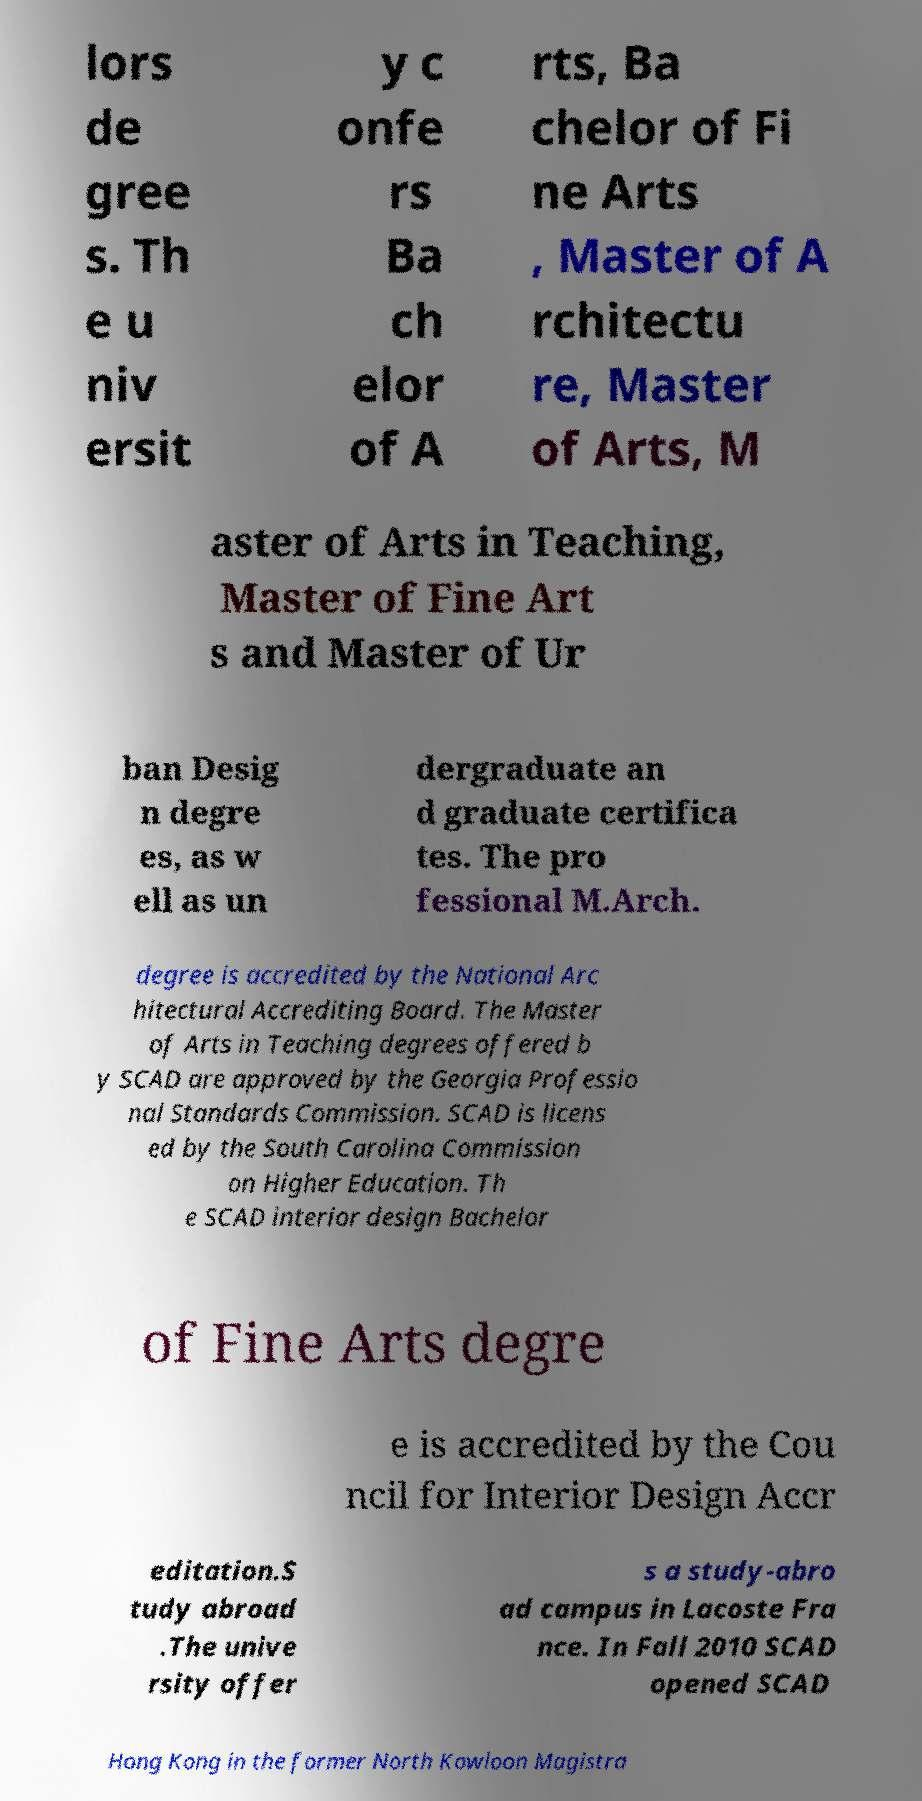Can you read and provide the text displayed in the image?This photo seems to have some interesting text. Can you extract and type it out for me? lors de gree s. Th e u niv ersit y c onfe rs Ba ch elor of A rts, Ba chelor of Fi ne Arts , Master of A rchitectu re, Master of Arts, M aster of Arts in Teaching, Master of Fine Art s and Master of Ur ban Desig n degre es, as w ell as un dergraduate an d graduate certifica tes. The pro fessional M.Arch. degree is accredited by the National Arc hitectural Accrediting Board. The Master of Arts in Teaching degrees offered b y SCAD are approved by the Georgia Professio nal Standards Commission. SCAD is licens ed by the South Carolina Commission on Higher Education. Th e SCAD interior design Bachelor of Fine Arts degre e is accredited by the Cou ncil for Interior Design Accr editation.S tudy abroad .The unive rsity offer s a study-abro ad campus in Lacoste Fra nce. In Fall 2010 SCAD opened SCAD Hong Kong in the former North Kowloon Magistra 